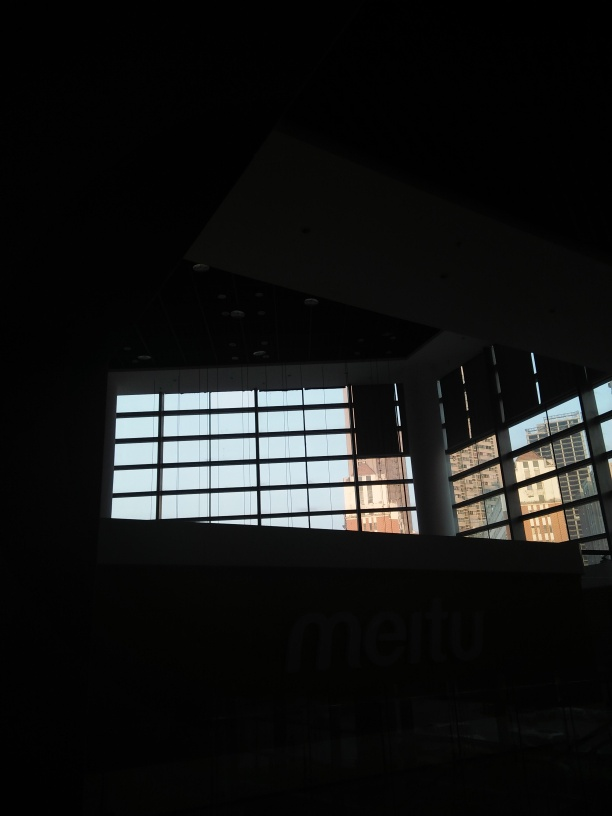What might be the reason for such underexposure in a photograph? Underexposure can occur for several reasons: the camera's shutter speed was too fast or the aperture too small to let in adequate light, the ISO setting was too low for the ambient conditions, or the camera metering was focused on a bright part of the scene, causing the camera to adjust for that brightness and thus underexpose the rest. 